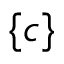<formula> <loc_0><loc_0><loc_500><loc_500>\{ c \}</formula> 